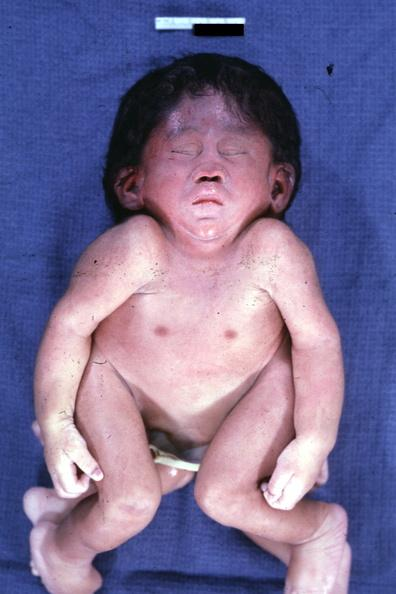s cephalothoracopagus janiceps present?
Answer the question using a single word or phrase. Yes 